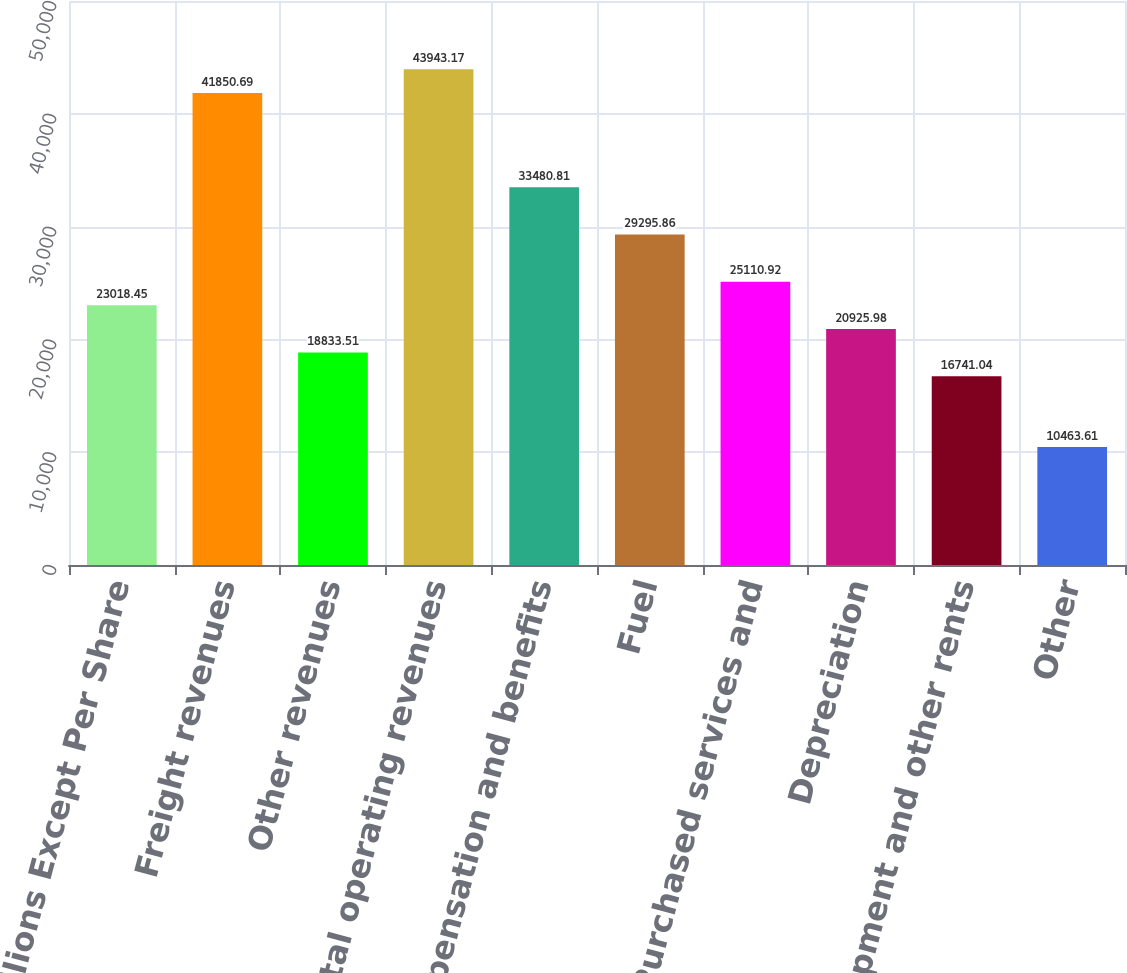Convert chart. <chart><loc_0><loc_0><loc_500><loc_500><bar_chart><fcel>Millions Except Per Share<fcel>Freight revenues<fcel>Other revenues<fcel>Total operating revenues<fcel>Compensation and benefits<fcel>Fuel<fcel>Purchased services and<fcel>Depreciation<fcel>Equipment and other rents<fcel>Other<nl><fcel>23018.5<fcel>41850.7<fcel>18833.5<fcel>43943.2<fcel>33480.8<fcel>29295.9<fcel>25110.9<fcel>20926<fcel>16741<fcel>10463.6<nl></chart> 